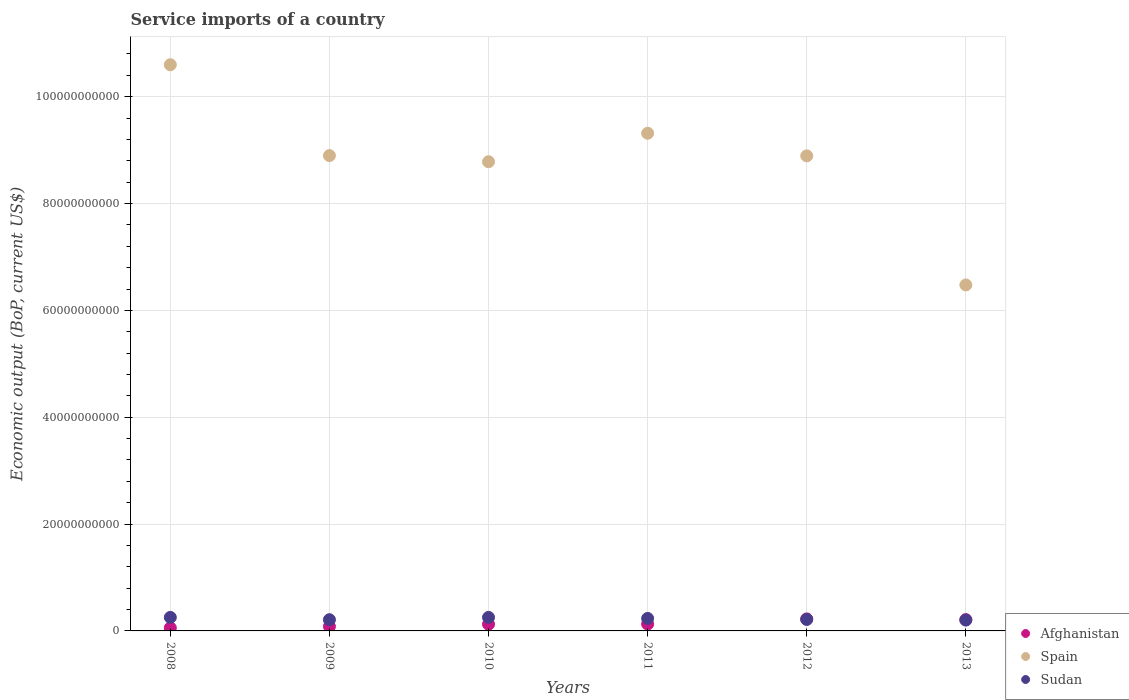Is the number of dotlines equal to the number of legend labels?
Provide a short and direct response. Yes. What is the service imports in Spain in 2009?
Make the answer very short. 8.90e+1. Across all years, what is the maximum service imports in Spain?
Give a very brief answer. 1.06e+11. Across all years, what is the minimum service imports in Sudan?
Offer a terse response. 2.03e+09. In which year was the service imports in Spain minimum?
Offer a very short reply. 2013. What is the total service imports in Sudan in the graph?
Give a very brief answer. 1.37e+1. What is the difference between the service imports in Sudan in 2008 and that in 2012?
Provide a succinct answer. 3.81e+08. What is the difference between the service imports in Sudan in 2008 and the service imports in Afghanistan in 2012?
Your answer should be very brief. 2.87e+08. What is the average service imports in Sudan per year?
Your response must be concise. 2.28e+09. In the year 2012, what is the difference between the service imports in Afghanistan and service imports in Sudan?
Keep it short and to the point. 9.36e+07. In how many years, is the service imports in Afghanistan greater than 80000000000 US$?
Offer a terse response. 0. What is the ratio of the service imports in Sudan in 2009 to that in 2010?
Offer a very short reply. 0.83. Is the difference between the service imports in Afghanistan in 2011 and 2013 greater than the difference between the service imports in Sudan in 2011 and 2013?
Your answer should be compact. No. What is the difference between the highest and the second highest service imports in Spain?
Your response must be concise. 1.28e+1. What is the difference between the highest and the lowest service imports in Afghanistan?
Give a very brief answer. 1.67e+09. Does the service imports in Spain monotonically increase over the years?
Give a very brief answer. No. Is the service imports in Spain strictly greater than the service imports in Sudan over the years?
Offer a very short reply. Yes. Is the service imports in Sudan strictly less than the service imports in Afghanistan over the years?
Your answer should be very brief. No. How many dotlines are there?
Provide a short and direct response. 3. How many years are there in the graph?
Make the answer very short. 6. Are the values on the major ticks of Y-axis written in scientific E-notation?
Offer a terse response. No. Does the graph contain grids?
Your response must be concise. Yes. How are the legend labels stacked?
Ensure brevity in your answer.  Vertical. What is the title of the graph?
Your response must be concise. Service imports of a country. Does "Central Europe" appear as one of the legend labels in the graph?
Give a very brief answer. No. What is the label or title of the X-axis?
Make the answer very short. Years. What is the label or title of the Y-axis?
Offer a terse response. Economic output (BoP, current US$). What is the Economic output (BoP, current US$) of Afghanistan in 2008?
Provide a short and direct response. 5.71e+08. What is the Economic output (BoP, current US$) of Spain in 2008?
Your response must be concise. 1.06e+11. What is the Economic output (BoP, current US$) in Sudan in 2008?
Make the answer very short. 2.53e+09. What is the Economic output (BoP, current US$) in Afghanistan in 2009?
Keep it short and to the point. 8.36e+08. What is the Economic output (BoP, current US$) in Spain in 2009?
Provide a succinct answer. 8.90e+1. What is the Economic output (BoP, current US$) in Sudan in 2009?
Ensure brevity in your answer.  2.10e+09. What is the Economic output (BoP, current US$) in Afghanistan in 2010?
Your answer should be compact. 1.26e+09. What is the Economic output (BoP, current US$) of Spain in 2010?
Make the answer very short. 8.78e+1. What is the Economic output (BoP, current US$) of Sudan in 2010?
Your response must be concise. 2.53e+09. What is the Economic output (BoP, current US$) in Afghanistan in 2011?
Offer a terse response. 1.29e+09. What is the Economic output (BoP, current US$) of Spain in 2011?
Provide a short and direct response. 9.32e+1. What is the Economic output (BoP, current US$) of Sudan in 2011?
Your answer should be compact. 2.34e+09. What is the Economic output (BoP, current US$) in Afghanistan in 2012?
Your answer should be very brief. 2.24e+09. What is the Economic output (BoP, current US$) in Spain in 2012?
Your response must be concise. 8.89e+1. What is the Economic output (BoP, current US$) in Sudan in 2012?
Make the answer very short. 2.15e+09. What is the Economic output (BoP, current US$) in Afghanistan in 2013?
Provide a succinct answer. 2.11e+09. What is the Economic output (BoP, current US$) of Spain in 2013?
Ensure brevity in your answer.  6.48e+1. What is the Economic output (BoP, current US$) in Sudan in 2013?
Ensure brevity in your answer.  2.03e+09. Across all years, what is the maximum Economic output (BoP, current US$) in Afghanistan?
Provide a short and direct response. 2.24e+09. Across all years, what is the maximum Economic output (BoP, current US$) of Spain?
Your answer should be compact. 1.06e+11. Across all years, what is the maximum Economic output (BoP, current US$) in Sudan?
Provide a short and direct response. 2.53e+09. Across all years, what is the minimum Economic output (BoP, current US$) of Afghanistan?
Make the answer very short. 5.71e+08. Across all years, what is the minimum Economic output (BoP, current US$) in Spain?
Your response must be concise. 6.48e+1. Across all years, what is the minimum Economic output (BoP, current US$) in Sudan?
Your response must be concise. 2.03e+09. What is the total Economic output (BoP, current US$) in Afghanistan in the graph?
Provide a succinct answer. 8.32e+09. What is the total Economic output (BoP, current US$) of Spain in the graph?
Give a very brief answer. 5.30e+11. What is the total Economic output (BoP, current US$) of Sudan in the graph?
Offer a very short reply. 1.37e+1. What is the difference between the Economic output (BoP, current US$) of Afghanistan in 2008 and that in 2009?
Ensure brevity in your answer.  -2.65e+08. What is the difference between the Economic output (BoP, current US$) in Spain in 2008 and that in 2009?
Make the answer very short. 1.70e+1. What is the difference between the Economic output (BoP, current US$) of Sudan in 2008 and that in 2009?
Provide a short and direct response. 4.31e+08. What is the difference between the Economic output (BoP, current US$) in Afghanistan in 2008 and that in 2010?
Offer a very short reply. -6.88e+08. What is the difference between the Economic output (BoP, current US$) of Spain in 2008 and that in 2010?
Provide a succinct answer. 1.82e+1. What is the difference between the Economic output (BoP, current US$) of Sudan in 2008 and that in 2010?
Give a very brief answer. -7.44e+05. What is the difference between the Economic output (BoP, current US$) of Afghanistan in 2008 and that in 2011?
Provide a succinct answer. -7.18e+08. What is the difference between the Economic output (BoP, current US$) of Spain in 2008 and that in 2011?
Provide a short and direct response. 1.28e+1. What is the difference between the Economic output (BoP, current US$) in Sudan in 2008 and that in 2011?
Provide a short and direct response. 1.94e+08. What is the difference between the Economic output (BoP, current US$) in Afghanistan in 2008 and that in 2012?
Your response must be concise. -1.67e+09. What is the difference between the Economic output (BoP, current US$) of Spain in 2008 and that in 2012?
Give a very brief answer. 1.71e+1. What is the difference between the Economic output (BoP, current US$) in Sudan in 2008 and that in 2012?
Keep it short and to the point. 3.81e+08. What is the difference between the Economic output (BoP, current US$) of Afghanistan in 2008 and that in 2013?
Your answer should be compact. -1.54e+09. What is the difference between the Economic output (BoP, current US$) of Spain in 2008 and that in 2013?
Ensure brevity in your answer.  4.12e+1. What is the difference between the Economic output (BoP, current US$) in Sudan in 2008 and that in 2013?
Your answer should be very brief. 5.02e+08. What is the difference between the Economic output (BoP, current US$) in Afghanistan in 2009 and that in 2010?
Your response must be concise. -4.23e+08. What is the difference between the Economic output (BoP, current US$) in Spain in 2009 and that in 2010?
Your response must be concise. 1.15e+09. What is the difference between the Economic output (BoP, current US$) of Sudan in 2009 and that in 2010?
Offer a terse response. -4.32e+08. What is the difference between the Economic output (BoP, current US$) in Afghanistan in 2009 and that in 2011?
Give a very brief answer. -4.54e+08. What is the difference between the Economic output (BoP, current US$) of Spain in 2009 and that in 2011?
Offer a terse response. -4.18e+09. What is the difference between the Economic output (BoP, current US$) of Sudan in 2009 and that in 2011?
Give a very brief answer. -2.37e+08. What is the difference between the Economic output (BoP, current US$) of Afghanistan in 2009 and that in 2012?
Ensure brevity in your answer.  -1.41e+09. What is the difference between the Economic output (BoP, current US$) of Spain in 2009 and that in 2012?
Ensure brevity in your answer.  5.04e+07. What is the difference between the Economic output (BoP, current US$) in Sudan in 2009 and that in 2012?
Make the answer very short. -5.01e+07. What is the difference between the Economic output (BoP, current US$) in Afghanistan in 2009 and that in 2013?
Make the answer very short. -1.28e+09. What is the difference between the Economic output (BoP, current US$) in Spain in 2009 and that in 2013?
Provide a succinct answer. 2.42e+1. What is the difference between the Economic output (BoP, current US$) in Sudan in 2009 and that in 2013?
Your answer should be very brief. 7.12e+07. What is the difference between the Economic output (BoP, current US$) of Afghanistan in 2010 and that in 2011?
Ensure brevity in your answer.  -3.05e+07. What is the difference between the Economic output (BoP, current US$) in Spain in 2010 and that in 2011?
Your answer should be very brief. -5.33e+09. What is the difference between the Economic output (BoP, current US$) of Sudan in 2010 and that in 2011?
Provide a short and direct response. 1.95e+08. What is the difference between the Economic output (BoP, current US$) in Afghanistan in 2010 and that in 2012?
Your response must be concise. -9.86e+08. What is the difference between the Economic output (BoP, current US$) in Spain in 2010 and that in 2012?
Keep it short and to the point. -1.10e+09. What is the difference between the Economic output (BoP, current US$) of Sudan in 2010 and that in 2012?
Keep it short and to the point. 3.82e+08. What is the difference between the Economic output (BoP, current US$) in Afghanistan in 2010 and that in 2013?
Your answer should be compact. -8.56e+08. What is the difference between the Economic output (BoP, current US$) of Spain in 2010 and that in 2013?
Your response must be concise. 2.31e+1. What is the difference between the Economic output (BoP, current US$) of Sudan in 2010 and that in 2013?
Keep it short and to the point. 5.03e+08. What is the difference between the Economic output (BoP, current US$) of Afghanistan in 2011 and that in 2012?
Offer a terse response. -9.55e+08. What is the difference between the Economic output (BoP, current US$) in Spain in 2011 and that in 2012?
Give a very brief answer. 4.23e+09. What is the difference between the Economic output (BoP, current US$) of Sudan in 2011 and that in 2012?
Offer a very short reply. 1.87e+08. What is the difference between the Economic output (BoP, current US$) of Afghanistan in 2011 and that in 2013?
Keep it short and to the point. -8.25e+08. What is the difference between the Economic output (BoP, current US$) of Spain in 2011 and that in 2013?
Offer a terse response. 2.84e+1. What is the difference between the Economic output (BoP, current US$) in Sudan in 2011 and that in 2013?
Make the answer very short. 3.08e+08. What is the difference between the Economic output (BoP, current US$) of Afghanistan in 2012 and that in 2013?
Make the answer very short. 1.30e+08. What is the difference between the Economic output (BoP, current US$) in Spain in 2012 and that in 2013?
Your answer should be compact. 2.42e+1. What is the difference between the Economic output (BoP, current US$) of Sudan in 2012 and that in 2013?
Keep it short and to the point. 1.21e+08. What is the difference between the Economic output (BoP, current US$) of Afghanistan in 2008 and the Economic output (BoP, current US$) of Spain in 2009?
Your answer should be compact. -8.84e+1. What is the difference between the Economic output (BoP, current US$) of Afghanistan in 2008 and the Economic output (BoP, current US$) of Sudan in 2009?
Ensure brevity in your answer.  -1.53e+09. What is the difference between the Economic output (BoP, current US$) in Spain in 2008 and the Economic output (BoP, current US$) in Sudan in 2009?
Give a very brief answer. 1.04e+11. What is the difference between the Economic output (BoP, current US$) in Afghanistan in 2008 and the Economic output (BoP, current US$) in Spain in 2010?
Offer a terse response. -8.73e+1. What is the difference between the Economic output (BoP, current US$) in Afghanistan in 2008 and the Economic output (BoP, current US$) in Sudan in 2010?
Keep it short and to the point. -1.96e+09. What is the difference between the Economic output (BoP, current US$) of Spain in 2008 and the Economic output (BoP, current US$) of Sudan in 2010?
Give a very brief answer. 1.03e+11. What is the difference between the Economic output (BoP, current US$) of Afghanistan in 2008 and the Economic output (BoP, current US$) of Spain in 2011?
Ensure brevity in your answer.  -9.26e+1. What is the difference between the Economic output (BoP, current US$) in Afghanistan in 2008 and the Economic output (BoP, current US$) in Sudan in 2011?
Offer a terse response. -1.77e+09. What is the difference between the Economic output (BoP, current US$) in Spain in 2008 and the Economic output (BoP, current US$) in Sudan in 2011?
Provide a succinct answer. 1.04e+11. What is the difference between the Economic output (BoP, current US$) in Afghanistan in 2008 and the Economic output (BoP, current US$) in Spain in 2012?
Provide a succinct answer. -8.84e+1. What is the difference between the Economic output (BoP, current US$) of Afghanistan in 2008 and the Economic output (BoP, current US$) of Sudan in 2012?
Make the answer very short. -1.58e+09. What is the difference between the Economic output (BoP, current US$) in Spain in 2008 and the Economic output (BoP, current US$) in Sudan in 2012?
Offer a very short reply. 1.04e+11. What is the difference between the Economic output (BoP, current US$) in Afghanistan in 2008 and the Economic output (BoP, current US$) in Spain in 2013?
Ensure brevity in your answer.  -6.42e+1. What is the difference between the Economic output (BoP, current US$) of Afghanistan in 2008 and the Economic output (BoP, current US$) of Sudan in 2013?
Your answer should be very brief. -1.46e+09. What is the difference between the Economic output (BoP, current US$) of Spain in 2008 and the Economic output (BoP, current US$) of Sudan in 2013?
Offer a terse response. 1.04e+11. What is the difference between the Economic output (BoP, current US$) of Afghanistan in 2009 and the Economic output (BoP, current US$) of Spain in 2010?
Provide a short and direct response. -8.70e+1. What is the difference between the Economic output (BoP, current US$) of Afghanistan in 2009 and the Economic output (BoP, current US$) of Sudan in 2010?
Make the answer very short. -1.70e+09. What is the difference between the Economic output (BoP, current US$) in Spain in 2009 and the Economic output (BoP, current US$) in Sudan in 2010?
Provide a succinct answer. 8.64e+1. What is the difference between the Economic output (BoP, current US$) of Afghanistan in 2009 and the Economic output (BoP, current US$) of Spain in 2011?
Make the answer very short. -9.23e+1. What is the difference between the Economic output (BoP, current US$) in Afghanistan in 2009 and the Economic output (BoP, current US$) in Sudan in 2011?
Your answer should be compact. -1.50e+09. What is the difference between the Economic output (BoP, current US$) in Spain in 2009 and the Economic output (BoP, current US$) in Sudan in 2011?
Offer a terse response. 8.66e+1. What is the difference between the Economic output (BoP, current US$) in Afghanistan in 2009 and the Economic output (BoP, current US$) in Spain in 2012?
Your answer should be compact. -8.81e+1. What is the difference between the Economic output (BoP, current US$) in Afghanistan in 2009 and the Economic output (BoP, current US$) in Sudan in 2012?
Make the answer very short. -1.32e+09. What is the difference between the Economic output (BoP, current US$) of Spain in 2009 and the Economic output (BoP, current US$) of Sudan in 2012?
Give a very brief answer. 8.68e+1. What is the difference between the Economic output (BoP, current US$) of Afghanistan in 2009 and the Economic output (BoP, current US$) of Spain in 2013?
Ensure brevity in your answer.  -6.39e+1. What is the difference between the Economic output (BoP, current US$) in Afghanistan in 2009 and the Economic output (BoP, current US$) in Sudan in 2013?
Make the answer very short. -1.19e+09. What is the difference between the Economic output (BoP, current US$) in Spain in 2009 and the Economic output (BoP, current US$) in Sudan in 2013?
Offer a terse response. 8.69e+1. What is the difference between the Economic output (BoP, current US$) in Afghanistan in 2010 and the Economic output (BoP, current US$) in Spain in 2011?
Your answer should be compact. -9.19e+1. What is the difference between the Economic output (BoP, current US$) of Afghanistan in 2010 and the Economic output (BoP, current US$) of Sudan in 2011?
Ensure brevity in your answer.  -1.08e+09. What is the difference between the Economic output (BoP, current US$) of Spain in 2010 and the Economic output (BoP, current US$) of Sudan in 2011?
Offer a terse response. 8.55e+1. What is the difference between the Economic output (BoP, current US$) in Afghanistan in 2010 and the Economic output (BoP, current US$) in Spain in 2012?
Make the answer very short. -8.77e+1. What is the difference between the Economic output (BoP, current US$) in Afghanistan in 2010 and the Economic output (BoP, current US$) in Sudan in 2012?
Your answer should be compact. -8.92e+08. What is the difference between the Economic output (BoP, current US$) of Spain in 2010 and the Economic output (BoP, current US$) of Sudan in 2012?
Offer a very short reply. 8.57e+1. What is the difference between the Economic output (BoP, current US$) of Afghanistan in 2010 and the Economic output (BoP, current US$) of Spain in 2013?
Offer a very short reply. -6.35e+1. What is the difference between the Economic output (BoP, current US$) in Afghanistan in 2010 and the Economic output (BoP, current US$) in Sudan in 2013?
Offer a terse response. -7.71e+08. What is the difference between the Economic output (BoP, current US$) in Spain in 2010 and the Economic output (BoP, current US$) in Sudan in 2013?
Your answer should be compact. 8.58e+1. What is the difference between the Economic output (BoP, current US$) of Afghanistan in 2011 and the Economic output (BoP, current US$) of Spain in 2012?
Your answer should be very brief. -8.76e+1. What is the difference between the Economic output (BoP, current US$) in Afghanistan in 2011 and the Economic output (BoP, current US$) in Sudan in 2012?
Give a very brief answer. -8.61e+08. What is the difference between the Economic output (BoP, current US$) of Spain in 2011 and the Economic output (BoP, current US$) of Sudan in 2012?
Provide a short and direct response. 9.10e+1. What is the difference between the Economic output (BoP, current US$) in Afghanistan in 2011 and the Economic output (BoP, current US$) in Spain in 2013?
Your response must be concise. -6.35e+1. What is the difference between the Economic output (BoP, current US$) of Afghanistan in 2011 and the Economic output (BoP, current US$) of Sudan in 2013?
Offer a very short reply. -7.40e+08. What is the difference between the Economic output (BoP, current US$) of Spain in 2011 and the Economic output (BoP, current US$) of Sudan in 2013?
Offer a very short reply. 9.11e+1. What is the difference between the Economic output (BoP, current US$) of Afghanistan in 2012 and the Economic output (BoP, current US$) of Spain in 2013?
Keep it short and to the point. -6.25e+1. What is the difference between the Economic output (BoP, current US$) in Afghanistan in 2012 and the Economic output (BoP, current US$) in Sudan in 2013?
Your answer should be very brief. 2.15e+08. What is the difference between the Economic output (BoP, current US$) in Spain in 2012 and the Economic output (BoP, current US$) in Sudan in 2013?
Offer a terse response. 8.69e+1. What is the average Economic output (BoP, current US$) in Afghanistan per year?
Provide a succinct answer. 1.39e+09. What is the average Economic output (BoP, current US$) in Spain per year?
Ensure brevity in your answer.  8.83e+1. What is the average Economic output (BoP, current US$) of Sudan per year?
Make the answer very short. 2.28e+09. In the year 2008, what is the difference between the Economic output (BoP, current US$) in Afghanistan and Economic output (BoP, current US$) in Spain?
Provide a succinct answer. -1.05e+11. In the year 2008, what is the difference between the Economic output (BoP, current US$) in Afghanistan and Economic output (BoP, current US$) in Sudan?
Give a very brief answer. -1.96e+09. In the year 2008, what is the difference between the Economic output (BoP, current US$) in Spain and Economic output (BoP, current US$) in Sudan?
Offer a terse response. 1.03e+11. In the year 2009, what is the difference between the Economic output (BoP, current US$) in Afghanistan and Economic output (BoP, current US$) in Spain?
Offer a very short reply. -8.81e+1. In the year 2009, what is the difference between the Economic output (BoP, current US$) in Afghanistan and Economic output (BoP, current US$) in Sudan?
Ensure brevity in your answer.  -1.26e+09. In the year 2009, what is the difference between the Economic output (BoP, current US$) of Spain and Economic output (BoP, current US$) of Sudan?
Offer a very short reply. 8.69e+1. In the year 2010, what is the difference between the Economic output (BoP, current US$) in Afghanistan and Economic output (BoP, current US$) in Spain?
Your response must be concise. -8.66e+1. In the year 2010, what is the difference between the Economic output (BoP, current US$) in Afghanistan and Economic output (BoP, current US$) in Sudan?
Provide a succinct answer. -1.27e+09. In the year 2010, what is the difference between the Economic output (BoP, current US$) of Spain and Economic output (BoP, current US$) of Sudan?
Keep it short and to the point. 8.53e+1. In the year 2011, what is the difference between the Economic output (BoP, current US$) of Afghanistan and Economic output (BoP, current US$) of Spain?
Give a very brief answer. -9.19e+1. In the year 2011, what is the difference between the Economic output (BoP, current US$) of Afghanistan and Economic output (BoP, current US$) of Sudan?
Ensure brevity in your answer.  -1.05e+09. In the year 2011, what is the difference between the Economic output (BoP, current US$) in Spain and Economic output (BoP, current US$) in Sudan?
Your answer should be compact. 9.08e+1. In the year 2012, what is the difference between the Economic output (BoP, current US$) in Afghanistan and Economic output (BoP, current US$) in Spain?
Keep it short and to the point. -8.67e+1. In the year 2012, what is the difference between the Economic output (BoP, current US$) in Afghanistan and Economic output (BoP, current US$) in Sudan?
Offer a very short reply. 9.36e+07. In the year 2012, what is the difference between the Economic output (BoP, current US$) in Spain and Economic output (BoP, current US$) in Sudan?
Offer a terse response. 8.68e+1. In the year 2013, what is the difference between the Economic output (BoP, current US$) of Afghanistan and Economic output (BoP, current US$) of Spain?
Provide a succinct answer. -6.26e+1. In the year 2013, what is the difference between the Economic output (BoP, current US$) in Afghanistan and Economic output (BoP, current US$) in Sudan?
Give a very brief answer. 8.50e+07. In the year 2013, what is the difference between the Economic output (BoP, current US$) of Spain and Economic output (BoP, current US$) of Sudan?
Offer a terse response. 6.27e+1. What is the ratio of the Economic output (BoP, current US$) of Afghanistan in 2008 to that in 2009?
Provide a short and direct response. 0.68. What is the ratio of the Economic output (BoP, current US$) of Spain in 2008 to that in 2009?
Ensure brevity in your answer.  1.19. What is the ratio of the Economic output (BoP, current US$) of Sudan in 2008 to that in 2009?
Keep it short and to the point. 1.21. What is the ratio of the Economic output (BoP, current US$) of Afghanistan in 2008 to that in 2010?
Give a very brief answer. 0.45. What is the ratio of the Economic output (BoP, current US$) of Spain in 2008 to that in 2010?
Keep it short and to the point. 1.21. What is the ratio of the Economic output (BoP, current US$) of Afghanistan in 2008 to that in 2011?
Provide a succinct answer. 0.44. What is the ratio of the Economic output (BoP, current US$) in Spain in 2008 to that in 2011?
Your answer should be compact. 1.14. What is the ratio of the Economic output (BoP, current US$) of Sudan in 2008 to that in 2011?
Provide a succinct answer. 1.08. What is the ratio of the Economic output (BoP, current US$) of Afghanistan in 2008 to that in 2012?
Your response must be concise. 0.25. What is the ratio of the Economic output (BoP, current US$) of Spain in 2008 to that in 2012?
Provide a succinct answer. 1.19. What is the ratio of the Economic output (BoP, current US$) in Sudan in 2008 to that in 2012?
Provide a succinct answer. 1.18. What is the ratio of the Economic output (BoP, current US$) in Afghanistan in 2008 to that in 2013?
Provide a short and direct response. 0.27. What is the ratio of the Economic output (BoP, current US$) in Spain in 2008 to that in 2013?
Provide a short and direct response. 1.64. What is the ratio of the Economic output (BoP, current US$) of Sudan in 2008 to that in 2013?
Your response must be concise. 1.25. What is the ratio of the Economic output (BoP, current US$) in Afghanistan in 2009 to that in 2010?
Your answer should be compact. 0.66. What is the ratio of the Economic output (BoP, current US$) of Spain in 2009 to that in 2010?
Provide a short and direct response. 1.01. What is the ratio of the Economic output (BoP, current US$) in Sudan in 2009 to that in 2010?
Make the answer very short. 0.83. What is the ratio of the Economic output (BoP, current US$) of Afghanistan in 2009 to that in 2011?
Offer a terse response. 0.65. What is the ratio of the Economic output (BoP, current US$) of Spain in 2009 to that in 2011?
Provide a short and direct response. 0.96. What is the ratio of the Economic output (BoP, current US$) in Sudan in 2009 to that in 2011?
Ensure brevity in your answer.  0.9. What is the ratio of the Economic output (BoP, current US$) in Afghanistan in 2009 to that in 2012?
Keep it short and to the point. 0.37. What is the ratio of the Economic output (BoP, current US$) in Sudan in 2009 to that in 2012?
Provide a short and direct response. 0.98. What is the ratio of the Economic output (BoP, current US$) of Afghanistan in 2009 to that in 2013?
Your answer should be compact. 0.4. What is the ratio of the Economic output (BoP, current US$) in Spain in 2009 to that in 2013?
Provide a succinct answer. 1.37. What is the ratio of the Economic output (BoP, current US$) of Sudan in 2009 to that in 2013?
Ensure brevity in your answer.  1.04. What is the ratio of the Economic output (BoP, current US$) of Afghanistan in 2010 to that in 2011?
Your answer should be compact. 0.98. What is the ratio of the Economic output (BoP, current US$) in Spain in 2010 to that in 2011?
Your response must be concise. 0.94. What is the ratio of the Economic output (BoP, current US$) of Sudan in 2010 to that in 2011?
Your answer should be compact. 1.08. What is the ratio of the Economic output (BoP, current US$) of Afghanistan in 2010 to that in 2012?
Your answer should be very brief. 0.56. What is the ratio of the Economic output (BoP, current US$) in Spain in 2010 to that in 2012?
Keep it short and to the point. 0.99. What is the ratio of the Economic output (BoP, current US$) in Sudan in 2010 to that in 2012?
Your response must be concise. 1.18. What is the ratio of the Economic output (BoP, current US$) in Afghanistan in 2010 to that in 2013?
Make the answer very short. 0.6. What is the ratio of the Economic output (BoP, current US$) in Spain in 2010 to that in 2013?
Provide a short and direct response. 1.36. What is the ratio of the Economic output (BoP, current US$) in Sudan in 2010 to that in 2013?
Your answer should be compact. 1.25. What is the ratio of the Economic output (BoP, current US$) of Afghanistan in 2011 to that in 2012?
Provide a short and direct response. 0.57. What is the ratio of the Economic output (BoP, current US$) of Spain in 2011 to that in 2012?
Offer a very short reply. 1.05. What is the ratio of the Economic output (BoP, current US$) in Sudan in 2011 to that in 2012?
Provide a short and direct response. 1.09. What is the ratio of the Economic output (BoP, current US$) of Afghanistan in 2011 to that in 2013?
Make the answer very short. 0.61. What is the ratio of the Economic output (BoP, current US$) of Spain in 2011 to that in 2013?
Your response must be concise. 1.44. What is the ratio of the Economic output (BoP, current US$) of Sudan in 2011 to that in 2013?
Make the answer very short. 1.15. What is the ratio of the Economic output (BoP, current US$) of Afghanistan in 2012 to that in 2013?
Provide a short and direct response. 1.06. What is the ratio of the Economic output (BoP, current US$) in Spain in 2012 to that in 2013?
Provide a short and direct response. 1.37. What is the ratio of the Economic output (BoP, current US$) of Sudan in 2012 to that in 2013?
Ensure brevity in your answer.  1.06. What is the difference between the highest and the second highest Economic output (BoP, current US$) in Afghanistan?
Give a very brief answer. 1.30e+08. What is the difference between the highest and the second highest Economic output (BoP, current US$) in Spain?
Provide a short and direct response. 1.28e+1. What is the difference between the highest and the second highest Economic output (BoP, current US$) of Sudan?
Make the answer very short. 7.44e+05. What is the difference between the highest and the lowest Economic output (BoP, current US$) of Afghanistan?
Offer a terse response. 1.67e+09. What is the difference between the highest and the lowest Economic output (BoP, current US$) of Spain?
Your response must be concise. 4.12e+1. What is the difference between the highest and the lowest Economic output (BoP, current US$) of Sudan?
Your answer should be compact. 5.03e+08. 